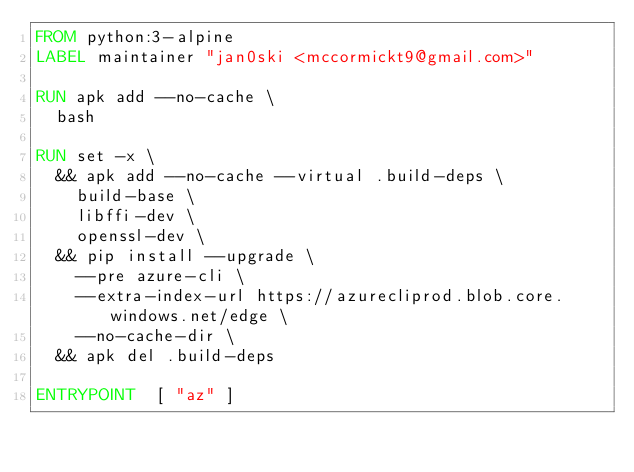<code> <loc_0><loc_0><loc_500><loc_500><_Dockerfile_>FROM python:3-alpine
LABEL maintainer "jan0ski <mccormickt9@gmail.com>"

RUN apk add --no-cache \
	bash

RUN set -x \
	&& apk add --no-cache --virtual .build-deps \
		build-base \
		libffi-dev \
		openssl-dev \
	&& pip install --upgrade \
		--pre azure-cli \
		--extra-index-url https://azurecliprod.blob.core.windows.net/edge \
		--no-cache-dir \
	&& apk del .build-deps

ENTRYPOINT	[ "az" ]
</code> 